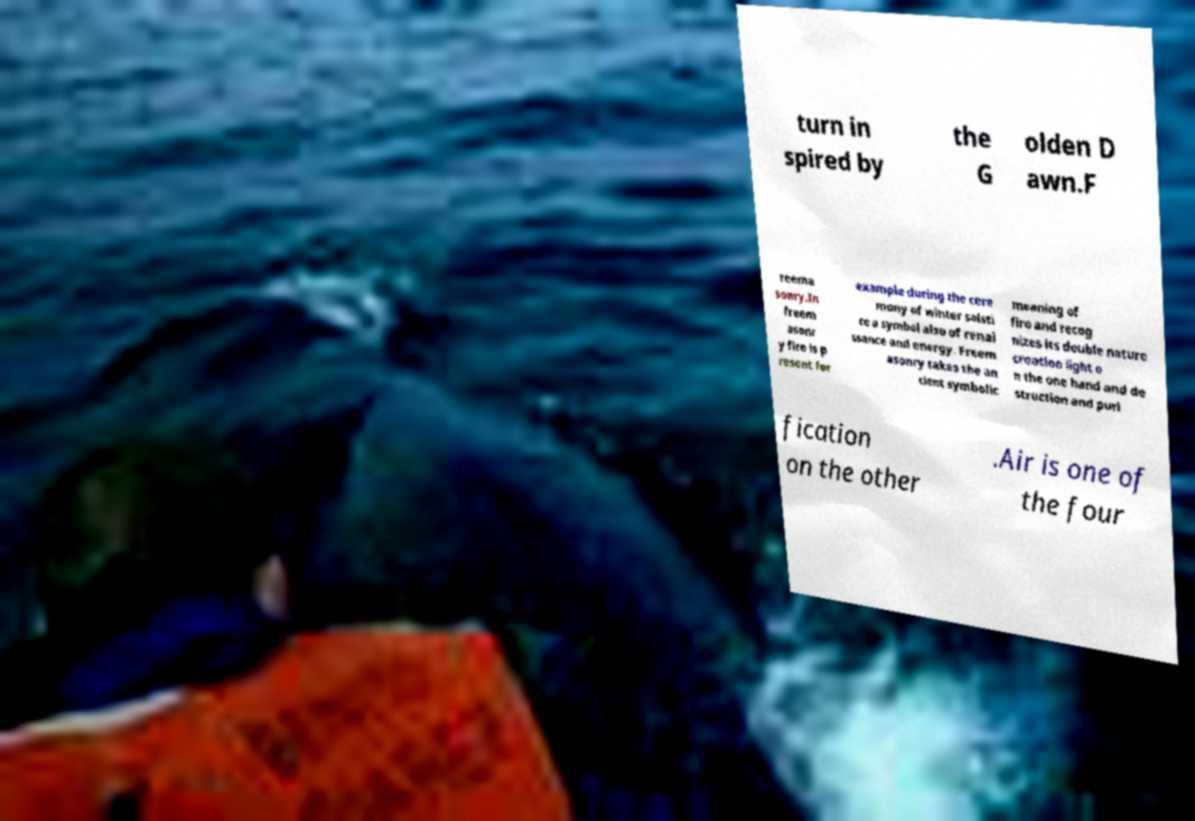Please read and relay the text visible in this image. What does it say? turn in spired by the G olden D awn.F reema sonry.In freem asonr y fire is p resent for example during the cere mony of winter solsti ce a symbol also of renai ssance and energy. Freem asonry takes the an cient symbolic meaning of fire and recog nizes its double nature creation light o n the one hand and de struction and puri fication on the other .Air is one of the four 